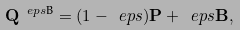<formula> <loc_0><loc_0><loc_500><loc_500>\mathbf Q ^ { \ e p s \text {B} } = ( 1 - \ e p s ) \mathbf P + \ e p s \mathbf B ,</formula> 